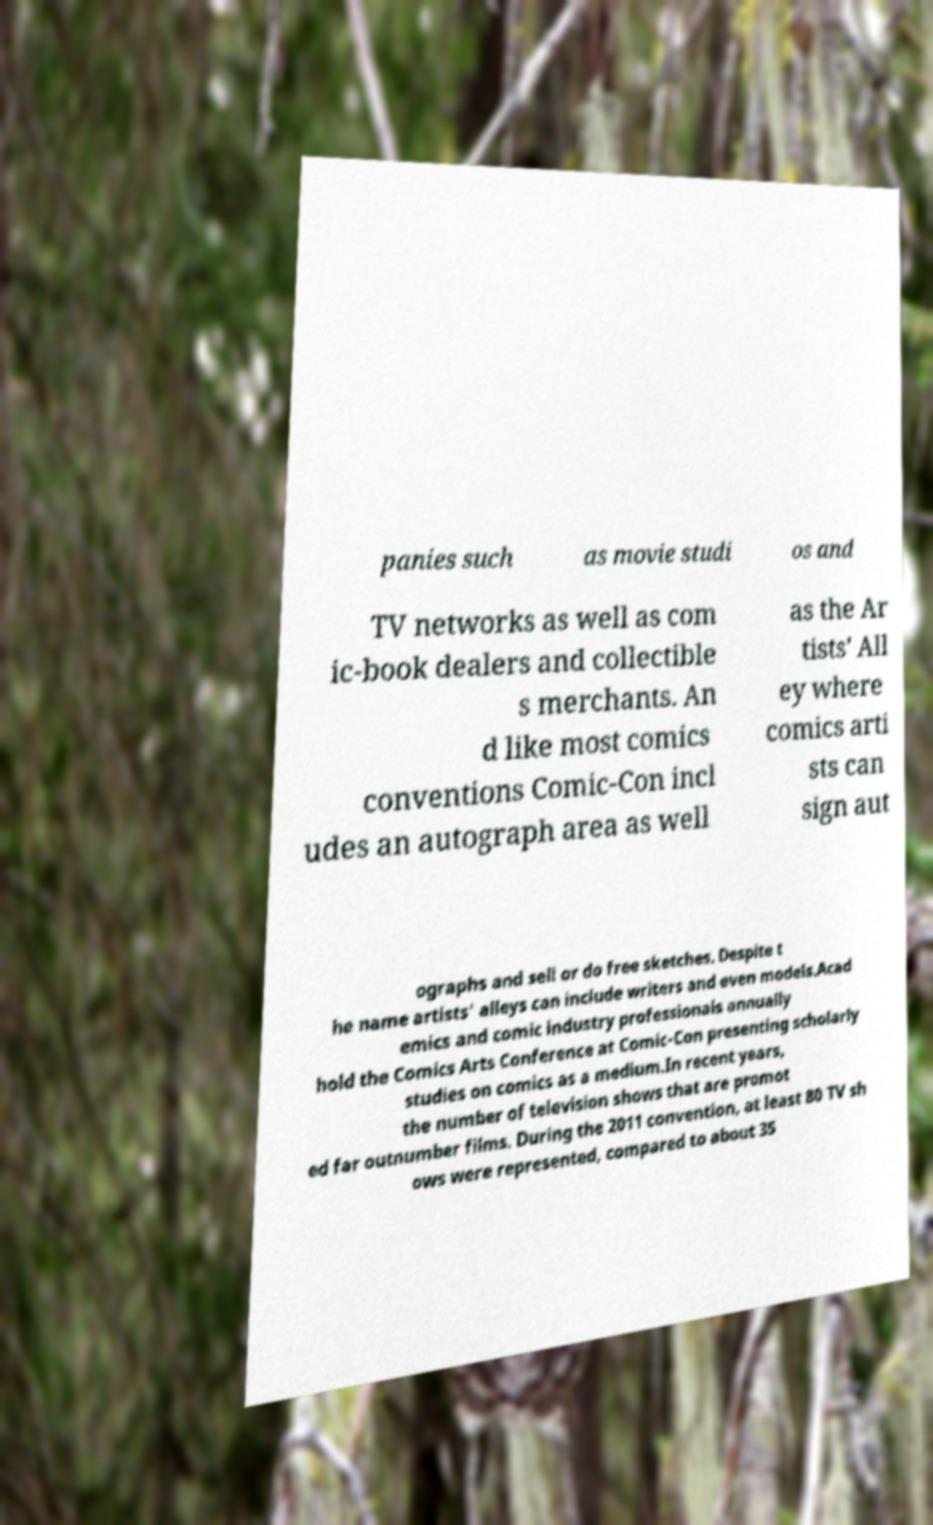Please read and relay the text visible in this image. What does it say? panies such as movie studi os and TV networks as well as com ic-book dealers and collectible s merchants. An d like most comics conventions Comic-Con incl udes an autograph area as well as the Ar tists' All ey where comics arti sts can sign aut ographs and sell or do free sketches. Despite t he name artists' alleys can include writers and even models.Acad emics and comic industry professionals annually hold the Comics Arts Conference at Comic-Con presenting scholarly studies on comics as a medium.In recent years, the number of television shows that are promot ed far outnumber films. During the 2011 convention, at least 80 TV sh ows were represented, compared to about 35 